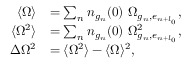<formula> <loc_0><loc_0><loc_500><loc_500>\begin{array} { r l } { \langle \Omega \rangle } & { = \sum _ { n } n _ { g _ { n } } ( 0 ) \ \Omega _ { g _ { n } , e _ { n + l _ { 0 } } } , } \\ { \langle \Omega ^ { 2 } \rangle } & { = \sum _ { n } n _ { g _ { n } } ( 0 ) \ \Omega _ { g _ { n } , e _ { n + l _ { 0 } } } ^ { 2 } , } \\ { \Delta \Omega ^ { 2 } } & { = \langle \Omega ^ { 2 } \rangle - \langle \Omega \rangle ^ { 2 } , } \end{array}</formula> 